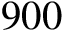<formula> <loc_0><loc_0><loc_500><loc_500>9 0 0</formula> 